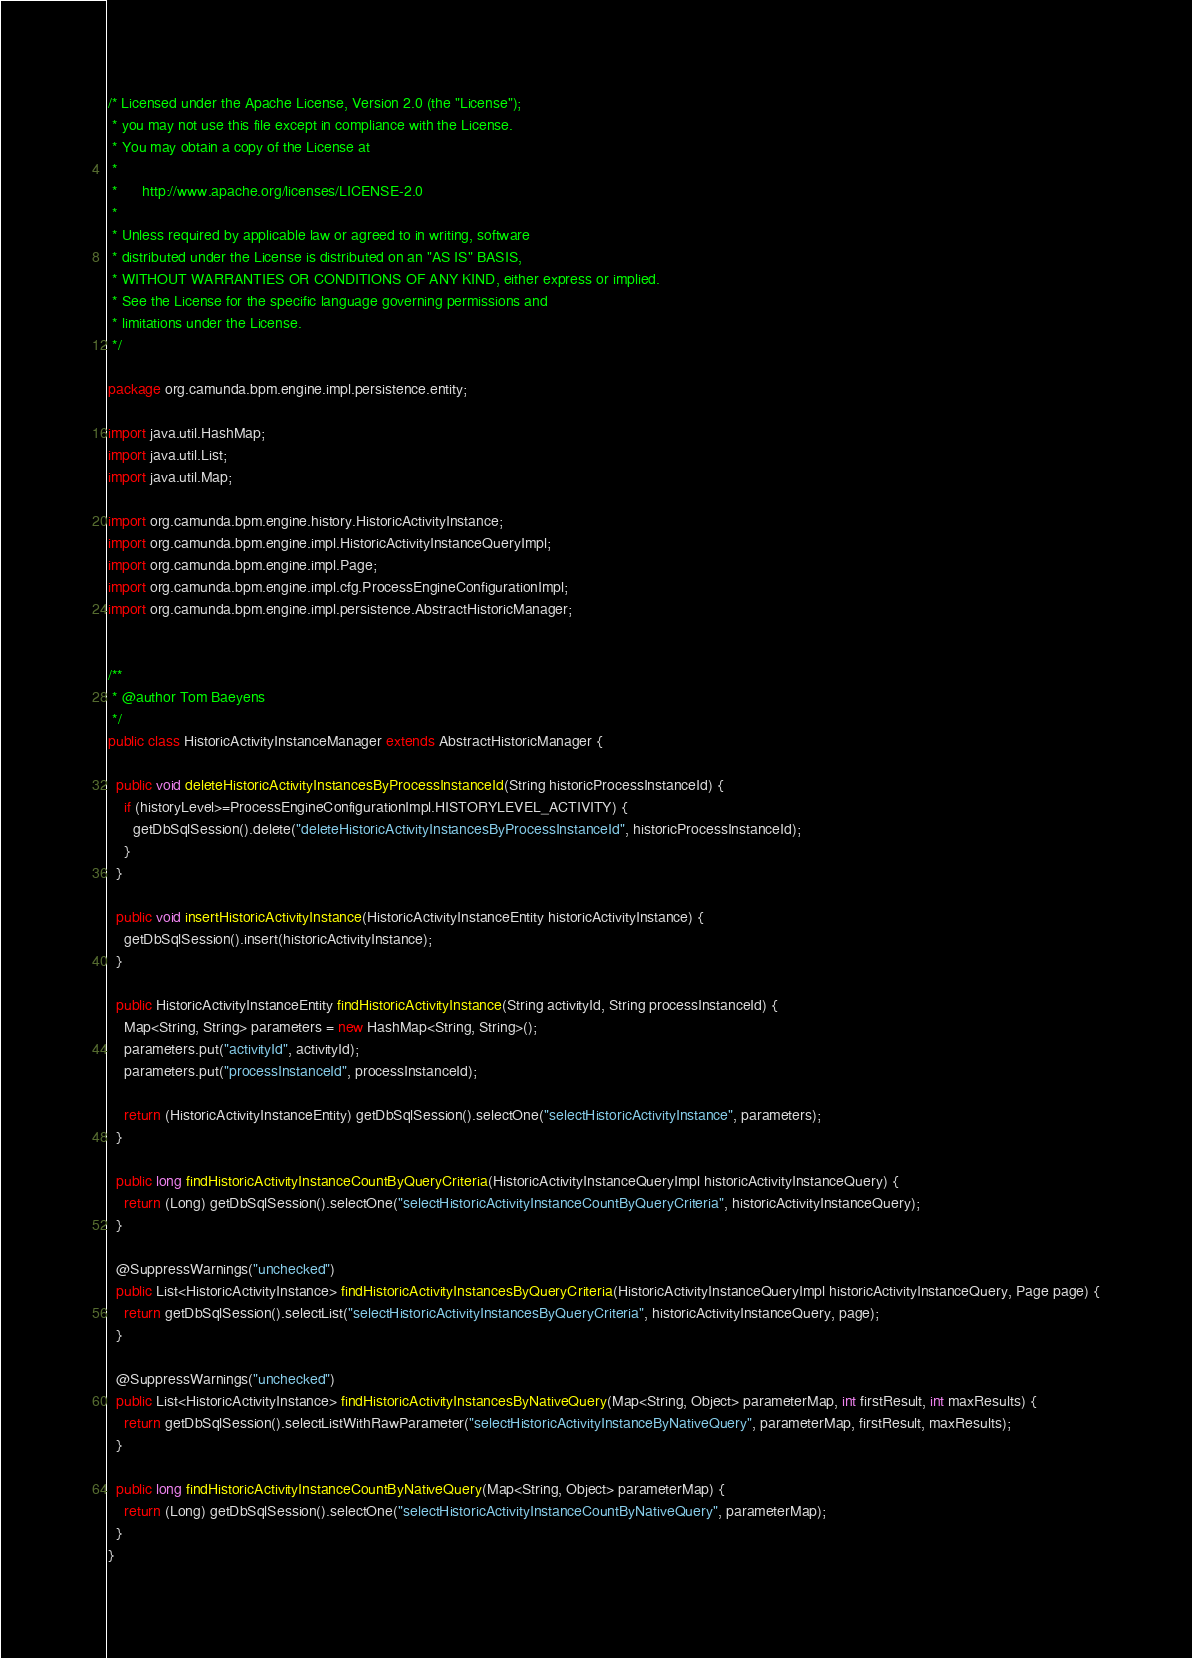<code> <loc_0><loc_0><loc_500><loc_500><_Java_>/* Licensed under the Apache License, Version 2.0 (the "License");
 * you may not use this file except in compliance with the License.
 * You may obtain a copy of the License at
 * 
 *      http://www.apache.org/licenses/LICENSE-2.0
 * 
 * Unless required by applicable law or agreed to in writing, software
 * distributed under the License is distributed on an "AS IS" BASIS,
 * WITHOUT WARRANTIES OR CONDITIONS OF ANY KIND, either express or implied.
 * See the License for the specific language governing permissions and
 * limitations under the License.
 */

package org.camunda.bpm.engine.impl.persistence.entity;

import java.util.HashMap;
import java.util.List;
import java.util.Map;

import org.camunda.bpm.engine.history.HistoricActivityInstance;
import org.camunda.bpm.engine.impl.HistoricActivityInstanceQueryImpl;
import org.camunda.bpm.engine.impl.Page;
import org.camunda.bpm.engine.impl.cfg.ProcessEngineConfigurationImpl;
import org.camunda.bpm.engine.impl.persistence.AbstractHistoricManager;


/**
 * @author Tom Baeyens
 */
public class HistoricActivityInstanceManager extends AbstractHistoricManager {

  public void deleteHistoricActivityInstancesByProcessInstanceId(String historicProcessInstanceId) {
    if (historyLevel>=ProcessEngineConfigurationImpl.HISTORYLEVEL_ACTIVITY) {
      getDbSqlSession().delete("deleteHistoricActivityInstancesByProcessInstanceId", historicProcessInstanceId);
    }
  }
  
  public void insertHistoricActivityInstance(HistoricActivityInstanceEntity historicActivityInstance) {
    getDbSqlSession().insert(historicActivityInstance);
  }

  public HistoricActivityInstanceEntity findHistoricActivityInstance(String activityId, String processInstanceId) {
    Map<String, String> parameters = new HashMap<String, String>();
    parameters.put("activityId", activityId);
    parameters.put("processInstanceId", processInstanceId);
  
    return (HistoricActivityInstanceEntity) getDbSqlSession().selectOne("selectHistoricActivityInstance", parameters);
  }

  public long findHistoricActivityInstanceCountByQueryCriteria(HistoricActivityInstanceQueryImpl historicActivityInstanceQuery) {
    return (Long) getDbSqlSession().selectOne("selectHistoricActivityInstanceCountByQueryCriteria", historicActivityInstanceQuery);
  }

  @SuppressWarnings("unchecked")
  public List<HistoricActivityInstance> findHistoricActivityInstancesByQueryCriteria(HistoricActivityInstanceQueryImpl historicActivityInstanceQuery, Page page) {
    return getDbSqlSession().selectList("selectHistoricActivityInstancesByQueryCriteria", historicActivityInstanceQuery, page);
  }

  @SuppressWarnings("unchecked")
  public List<HistoricActivityInstance> findHistoricActivityInstancesByNativeQuery(Map<String, Object> parameterMap, int firstResult, int maxResults) {
    return getDbSqlSession().selectListWithRawParameter("selectHistoricActivityInstanceByNativeQuery", parameterMap, firstResult, maxResults);
  }

  public long findHistoricActivityInstanceCountByNativeQuery(Map<String, Object> parameterMap) {
    return (Long) getDbSqlSession().selectOne("selectHistoricActivityInstanceCountByNativeQuery", parameterMap);
  }
}
</code> 